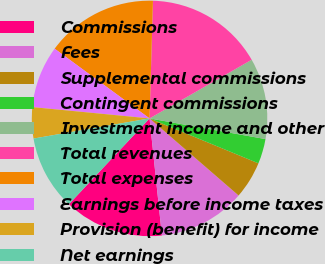Convert chart. <chart><loc_0><loc_0><loc_500><loc_500><pie_chart><fcel>Commissions<fcel>Fees<fcel>Supplemental commissions<fcel>Contingent commissions<fcel>Investment income and other<fcel>Total revenues<fcel>Total expenses<fcel>Earnings before income taxes<fcel>Provision (benefit) for income<fcel>Net earnings<nl><fcel>13.68%<fcel>11.97%<fcel>5.13%<fcel>3.42%<fcel>11.11%<fcel>16.24%<fcel>15.38%<fcel>8.55%<fcel>4.27%<fcel>10.26%<nl></chart> 